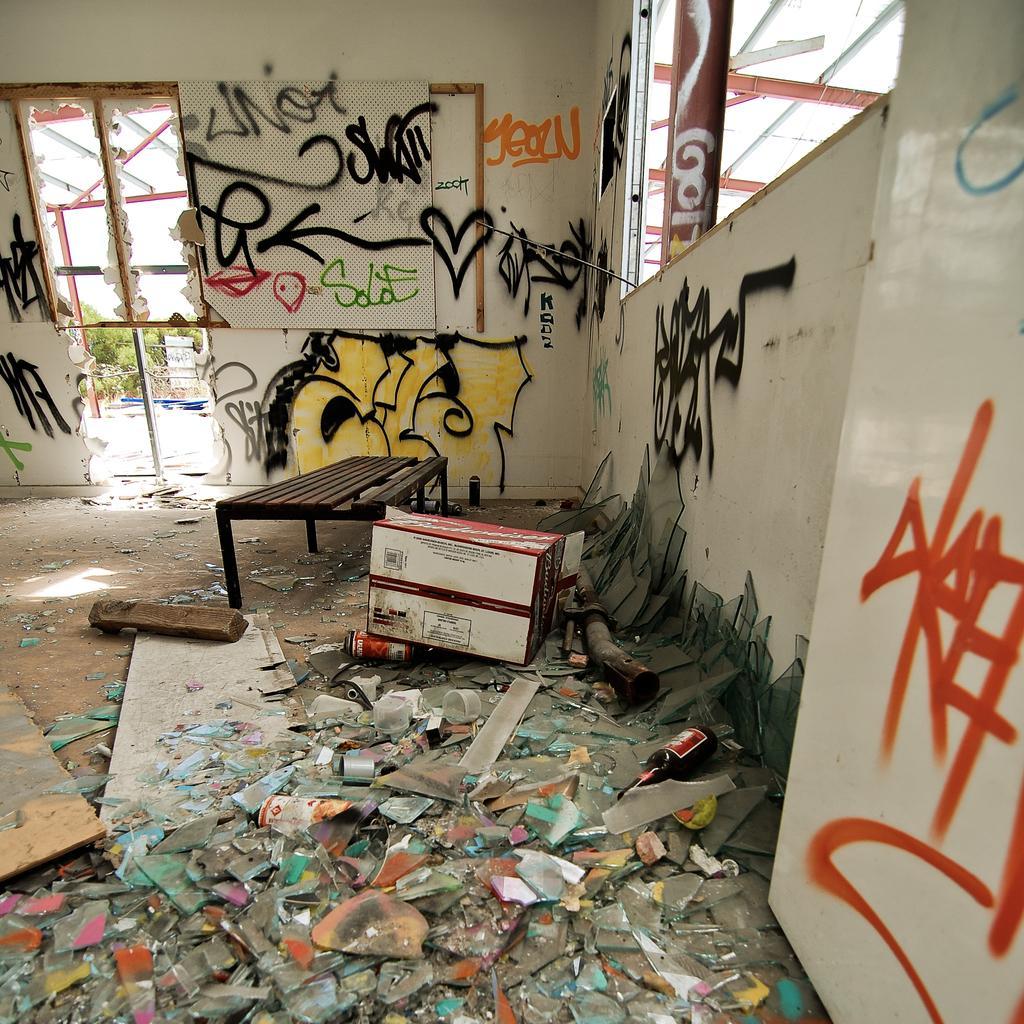Could you give a brief overview of what you see in this image? At the bottom of the image there on the floor there are many glass pieces and also there are bottles and wooden pieces. And there is a cardboard box and bench. In the background there is wall with names. There are few places with broken walls. Outside the broken wall there are trees. 